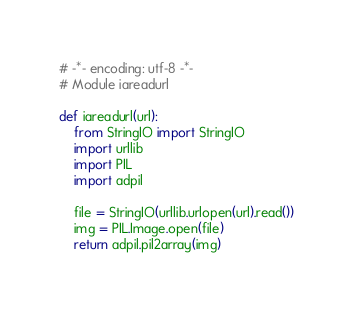Convert code to text. <code><loc_0><loc_0><loc_500><loc_500><_Python_># -*- encoding: utf-8 -*-
# Module iareadurl

def iareadurl(url):
    from StringIO import StringIO
    import urllib
    import PIL
    import adpil

    file = StringIO(urllib.urlopen(url).read())
    img = PIL.Image.open(file)
    return adpil.pil2array(img)

</code> 